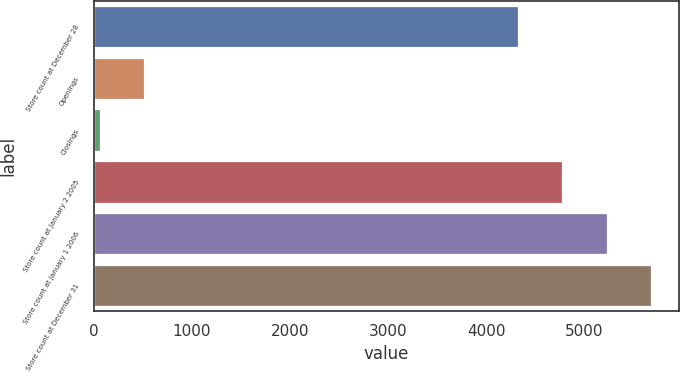Convert chart. <chart><loc_0><loc_0><loc_500><loc_500><bar_chart><fcel>Store count at December 28<fcel>Openings<fcel>Closings<fcel>Store count at January 2 2005<fcel>Store count at January 1 2006<fcel>Store count at December 31<nl><fcel>4327<fcel>515.7<fcel>65<fcel>4777.7<fcel>5228.4<fcel>5679.1<nl></chart> 